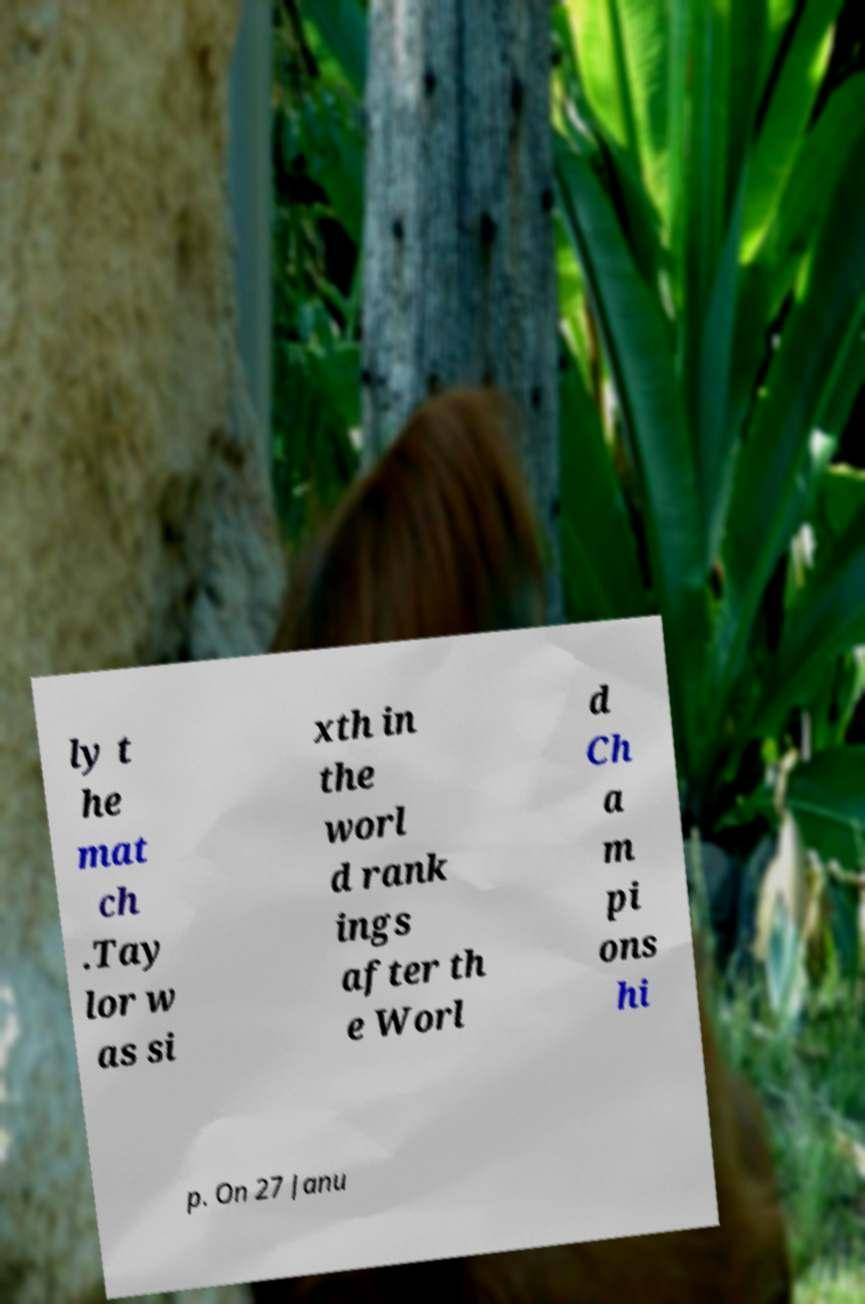Please identify and transcribe the text found in this image. ly t he mat ch .Tay lor w as si xth in the worl d rank ings after th e Worl d Ch a m pi ons hi p. On 27 Janu 